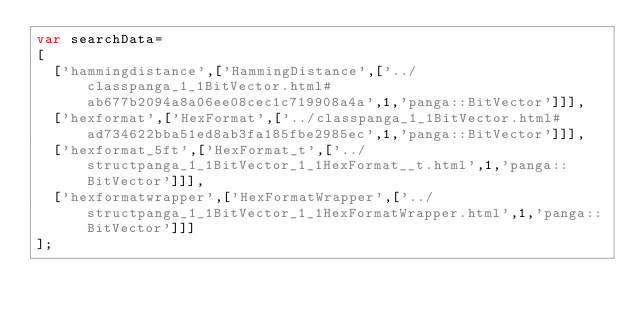<code> <loc_0><loc_0><loc_500><loc_500><_JavaScript_>var searchData=
[
  ['hammingdistance',['HammingDistance',['../classpanga_1_1BitVector.html#ab677b2094a8a06ee08cec1c719908a4a',1,'panga::BitVector']]],
  ['hexformat',['HexFormat',['../classpanga_1_1BitVector.html#ad734622bba51ed8ab3fa185fbe2985ec',1,'panga::BitVector']]],
  ['hexformat_5ft',['HexFormat_t',['../structpanga_1_1BitVector_1_1HexFormat__t.html',1,'panga::BitVector']]],
  ['hexformatwrapper',['HexFormatWrapper',['../structpanga_1_1BitVector_1_1HexFormatWrapper.html',1,'panga::BitVector']]]
];
</code> 